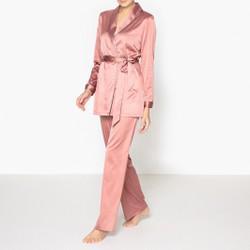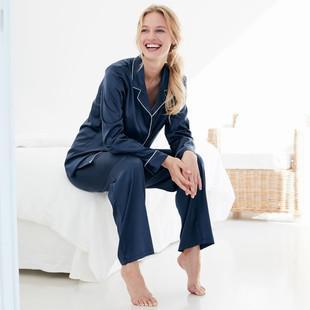The first image is the image on the left, the second image is the image on the right. Examine the images to the left and right. Is the description "One model is wearing purple pajamas and sitting cross-legged on the floor in front of a tufted sofa." accurate? Answer yes or no. No. The first image is the image on the left, the second image is the image on the right. Examine the images to the left and right. Is the description "A solid colored pajama set has long pants paired with a long sleeved shirt with contrasting piping on the shirt cuffs and collar." accurate? Answer yes or no. Yes. 